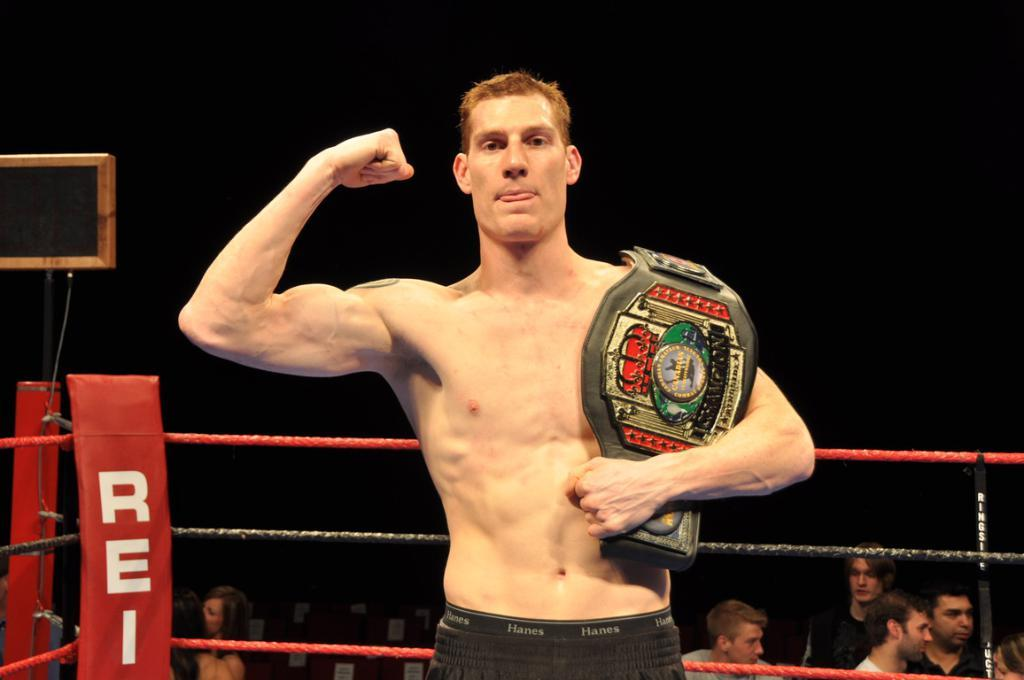<image>
Render a clear and concise summary of the photo. A man standing inside of an REI ring proudly holds a winners belt 